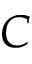<formula> <loc_0><loc_0><loc_500><loc_500>C</formula> 